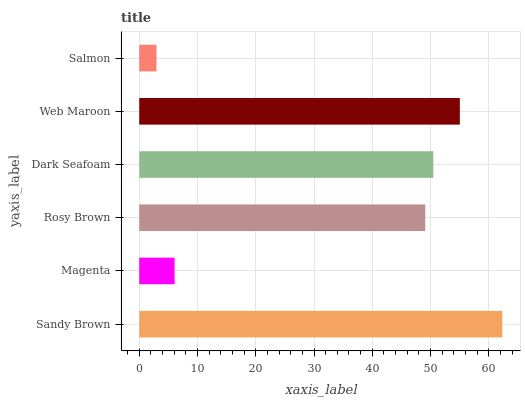Is Salmon the minimum?
Answer yes or no. Yes. Is Sandy Brown the maximum?
Answer yes or no. Yes. Is Magenta the minimum?
Answer yes or no. No. Is Magenta the maximum?
Answer yes or no. No. Is Sandy Brown greater than Magenta?
Answer yes or no. Yes. Is Magenta less than Sandy Brown?
Answer yes or no. Yes. Is Magenta greater than Sandy Brown?
Answer yes or no. No. Is Sandy Brown less than Magenta?
Answer yes or no. No. Is Dark Seafoam the high median?
Answer yes or no. Yes. Is Rosy Brown the low median?
Answer yes or no. Yes. Is Rosy Brown the high median?
Answer yes or no. No. Is Dark Seafoam the low median?
Answer yes or no. No. 